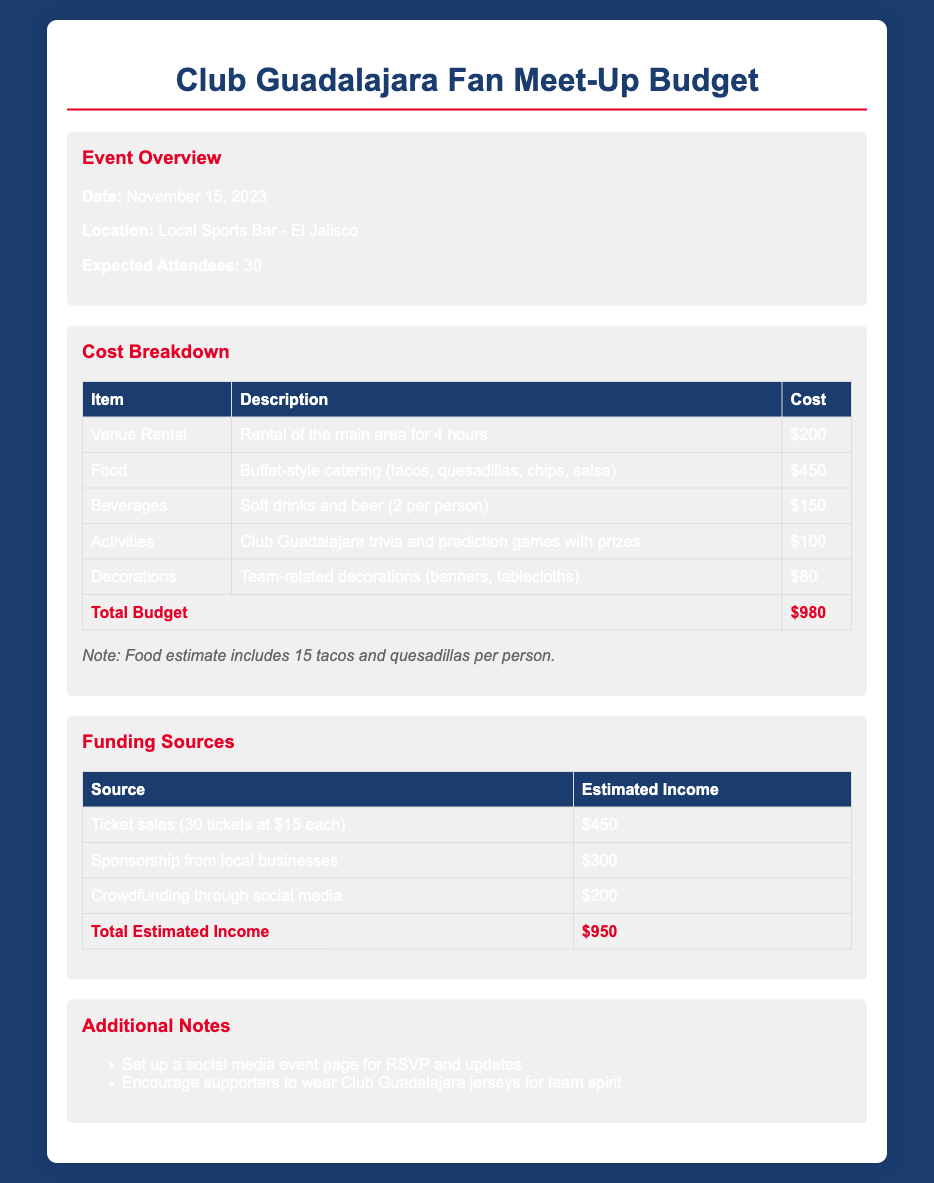What is the date of the event? The document states that the event is scheduled for November 15, 2023.
Answer: November 15, 2023 What is the location of the meet-up? According to the document, the location of the meet-up is local sports bar El Jalisco.
Answer: El Jalisco How many expected attendees are there? The document mentions that there are 30 expected attendees for the event.
Answer: 30 What is the cost for venue rental? The budget outlines that the venue rental costs $200.
Answer: $200 What is included in the food budget? The food budget includes buffet-style catering with tacos, quesadillas, chips, and salsa.
Answer: Tacos, quesadillas, chips, salsa What are the total estimated income sources? The total estimated income sources are ticket sales, sponsorship, and crowdfunding, which amounts to $950.
Answer: $950 How much does the activities segment of the budget cost? The activities section for Club Guadalajara trivia and prediction games is budgeted at $100.
Answer: $100 What is the total budget for the event? The total budget for the event is calculated as $980.
Answer: $980 What items in the budget include decorations? Decorations include team-related items such as banners and tablecloths, listed at $80.
Answer: Banners, tablecloths How many soft drinks and beers are accounted for per person? The budget specifies 2 soft drinks and beers per person within the beverages cost.
Answer: 2 per person 